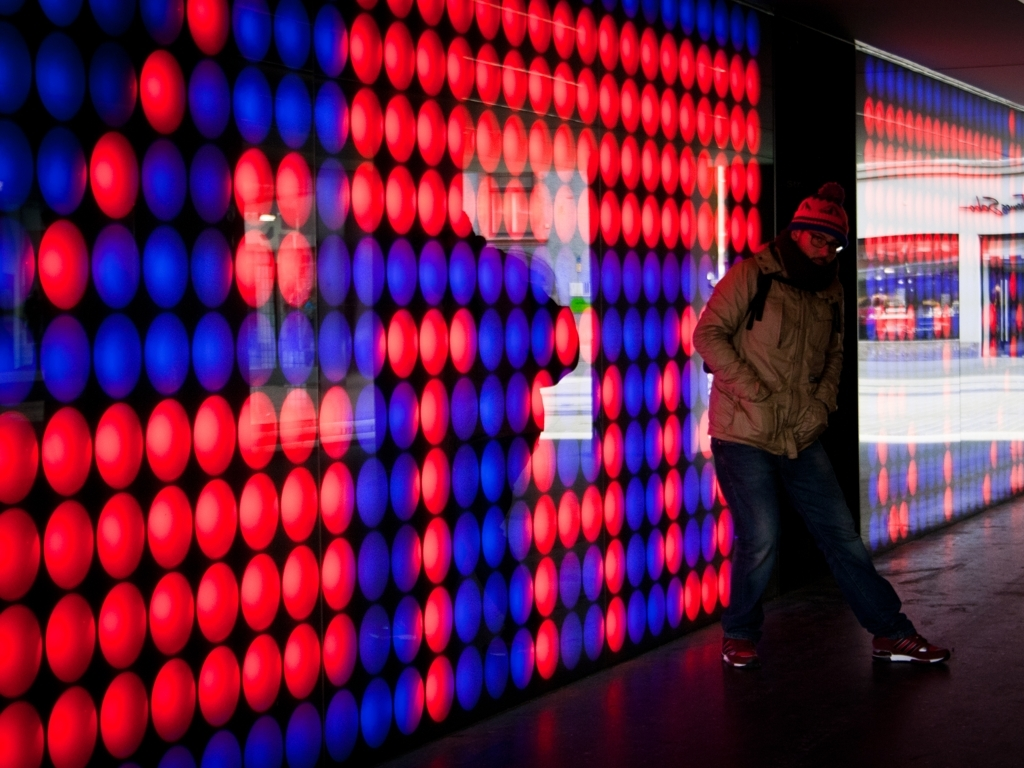Can you tell me more about the person in the image? While we should not make assumptions about individuals, the person in the image appears to be casually dressed, suggesting a relaxed or informal setting. Their stance and the inclination of the head might suggest they are observing or interacting with the light display. What could the blurriness of the lights in the background suggest? The blurriness of the lights likely indicates motion, suggesting that the light source is dynamic, which can signify energy, change, or the passage of time in the scene. 